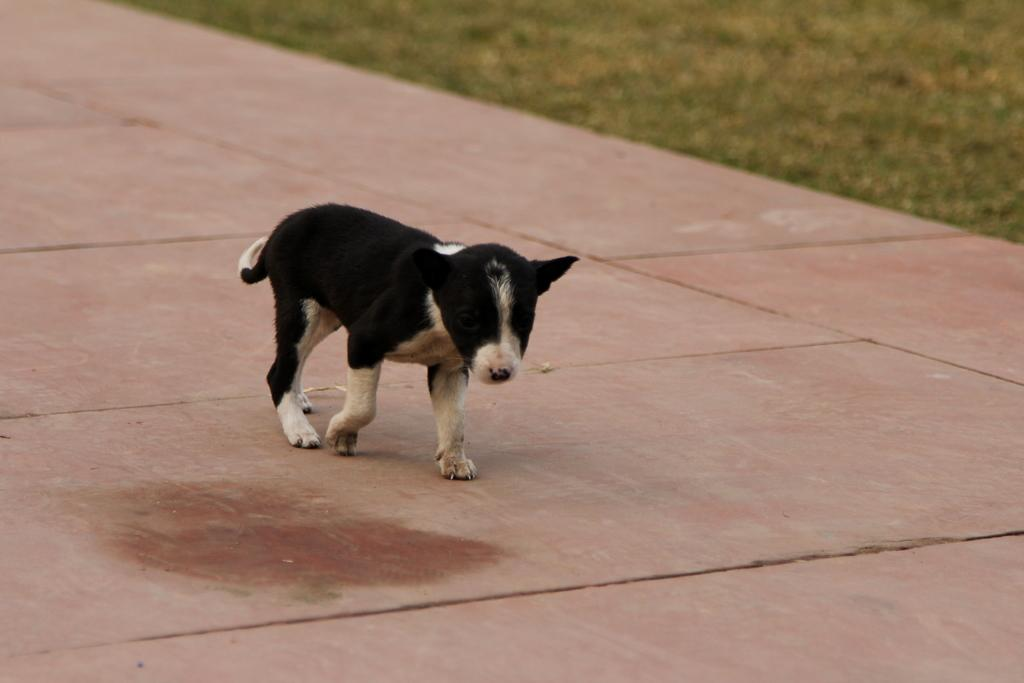What type of animal is present in the image? There is a dog in the image. How many quarters does the dog have in the image? There are no quarters present in the image; it features a dog. What type of farewell is the dog saying in the image? The dog is not saying good-bye in the image, as it is an animal and cannot speak. 